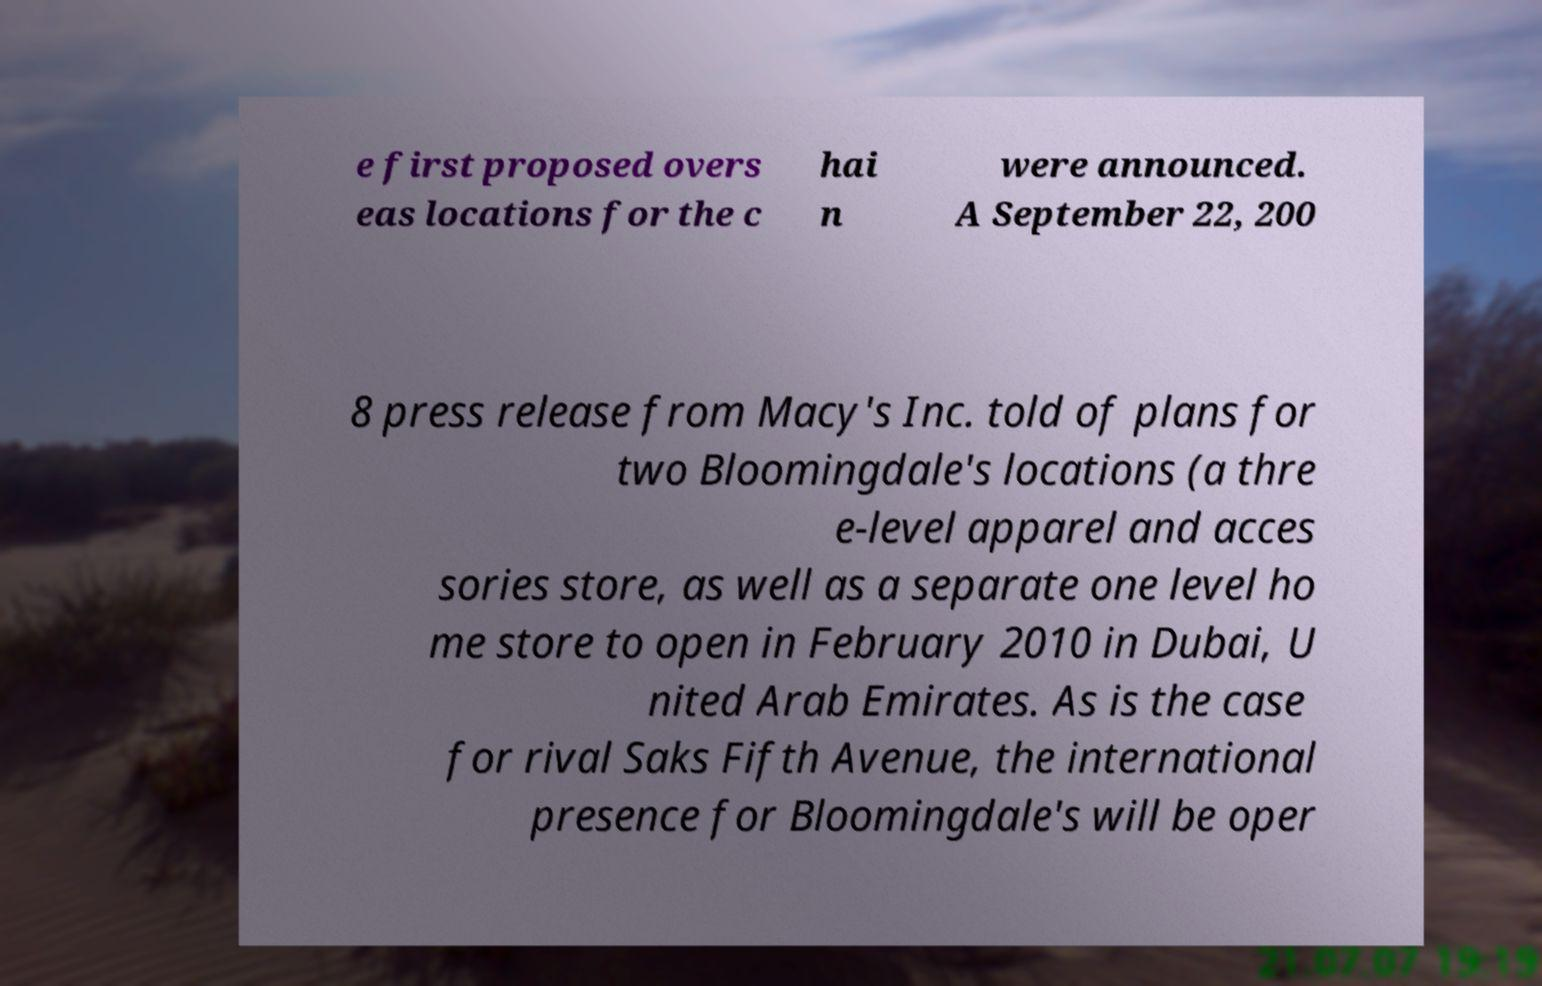I need the written content from this picture converted into text. Can you do that? e first proposed overs eas locations for the c hai n were announced. A September 22, 200 8 press release from Macy's Inc. told of plans for two Bloomingdale's locations (a thre e-level apparel and acces sories store, as well as a separate one level ho me store to open in February 2010 in Dubai, U nited Arab Emirates. As is the case for rival Saks Fifth Avenue, the international presence for Bloomingdale's will be oper 